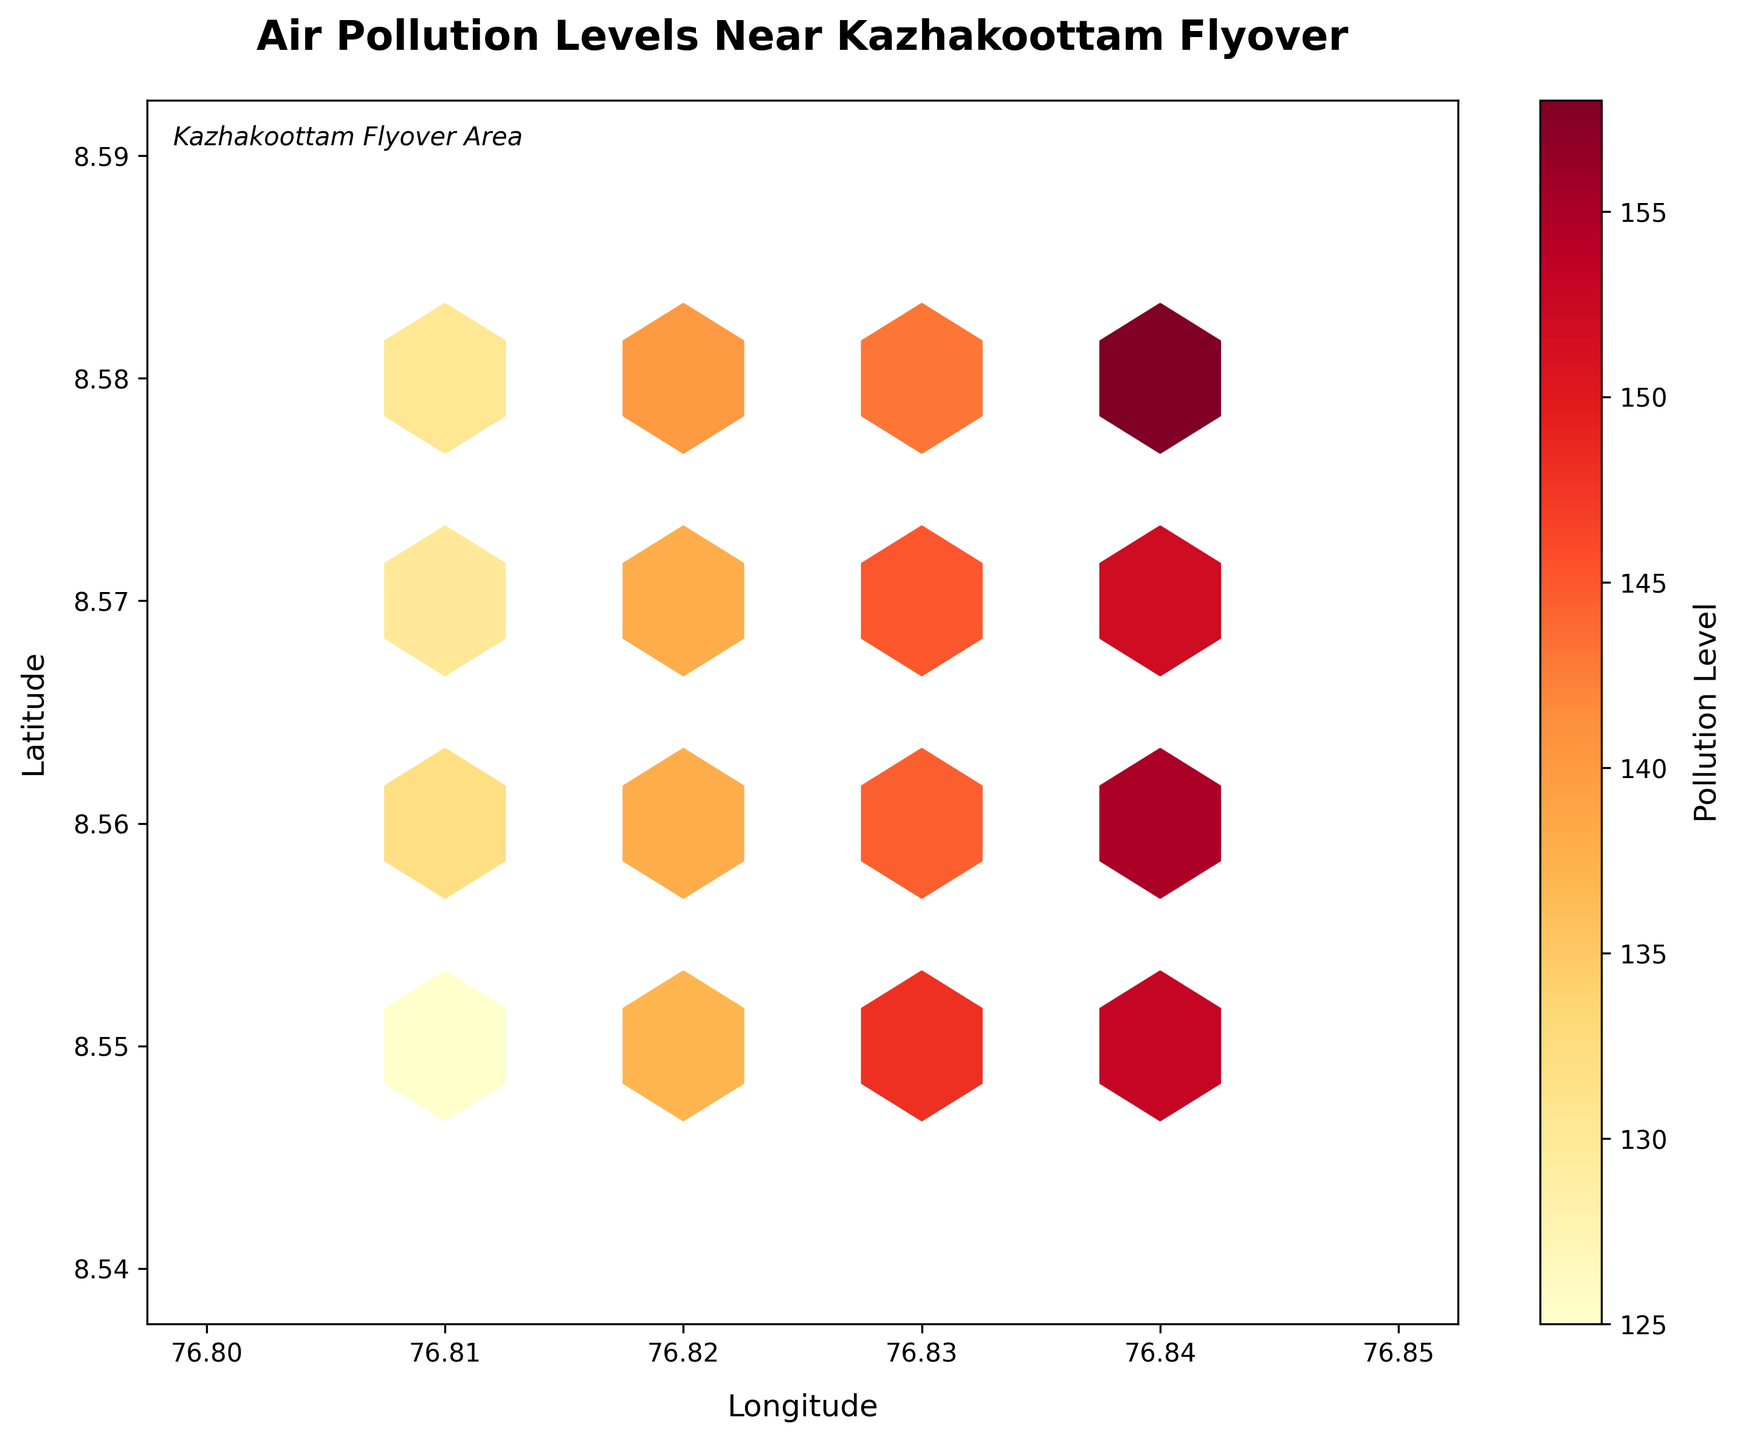What is the title of the hexbin plot? The title is displayed at the top of the plot, providing an overview of the plot's content.
Answer: Air Pollution Levels Near Kazhakoottam Flyover What do the x and y axes represent in the plot? The labels on the x and y axes indicate the dimensions being plotted. The x-axis represents Longitude, and the y-axis represents Latitude.
Answer: Longitude and Latitude What does the color indicate in the hexbin plot? The color scheme of the hexagons represents the air pollution levels, as indicated by the color bar to the right of the plot.
Answer: Pollution Level Around what latitudes do the highest pollution levels appear on the plot? The hexagons with the darkest colors (indicating the highest pollution levels) are concentrated around specific latitude bands on the y-axis.
Answer: 8.55 to 8.58 Are there areas with no pollution data? The absence of hexagons in certain grids of the plot indicates areas where no data points were collected or plotted.
Answer: Yes Which area shows the highest pollution level, and what is that level? By looking at the color bar and the darkest hexagon, we can identify the area and its corresponding pollution level. The grid near 76.84 (Longitude) and 8.56 (Latitude) has the highest pollution level.
Answer: Near 76.84, 8.56; Level: around 158 Compare the pollution levels at 76.83 longitude for latitudes 8.55 and 8.57. Which is higher? Check the color shades of the hexagons at the specified points. The darker color indicates a higher pollution level.
Answer: 8.57 What can be inferred from the pollution levels between 76.81 and 76.82 longitude? Analyzing the color gradients between these longitudes provides insights into pollution variation across this area.
Answer: Moderate pollution Which region has the least air pollution levels according to the plot? Identify the lightest-colored hexagons or areas with less intense colors to determine regions with lower pollution levels.
Answer: Near 76.81, 8.55 How do the pollution levels change from 76.81 to 76.84 longitude along the latitude of 8.56? Evaluate the color intensity changes in hexagons aligned with 8.56 latitude from 76.81 to 76.84 to derive the trend. The color intensifies midway, indicating varying pollution levels.
Answer: Increases then peaks near the middle 